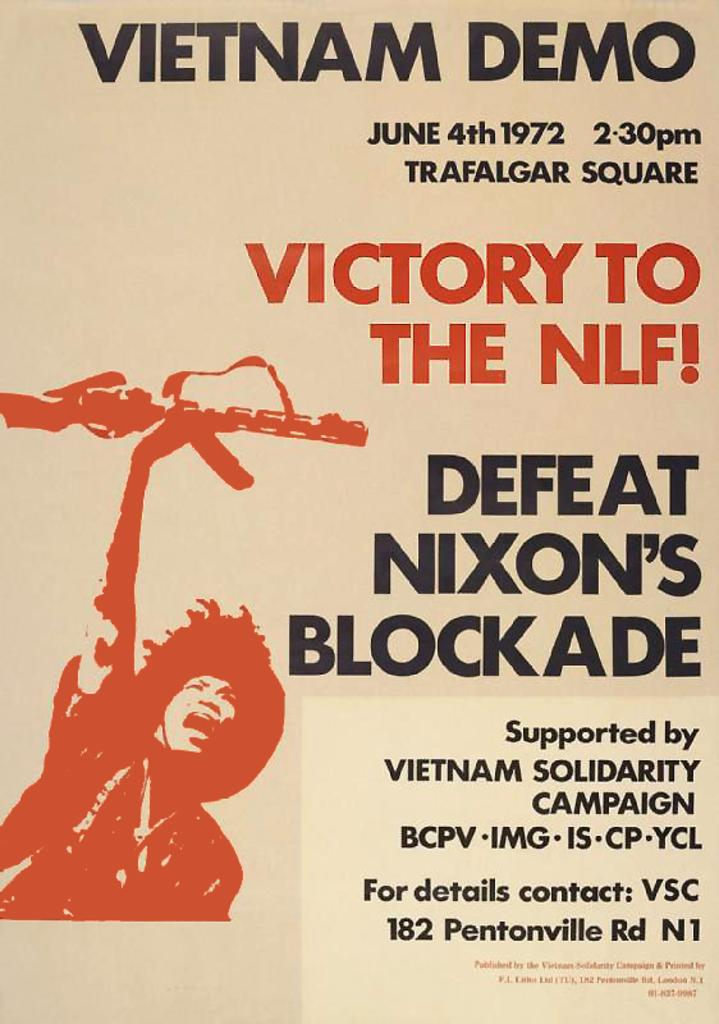<image>
Present a compact description of the photo's key features. A poster that is for a demonstration against Nixon in Vietnam. 